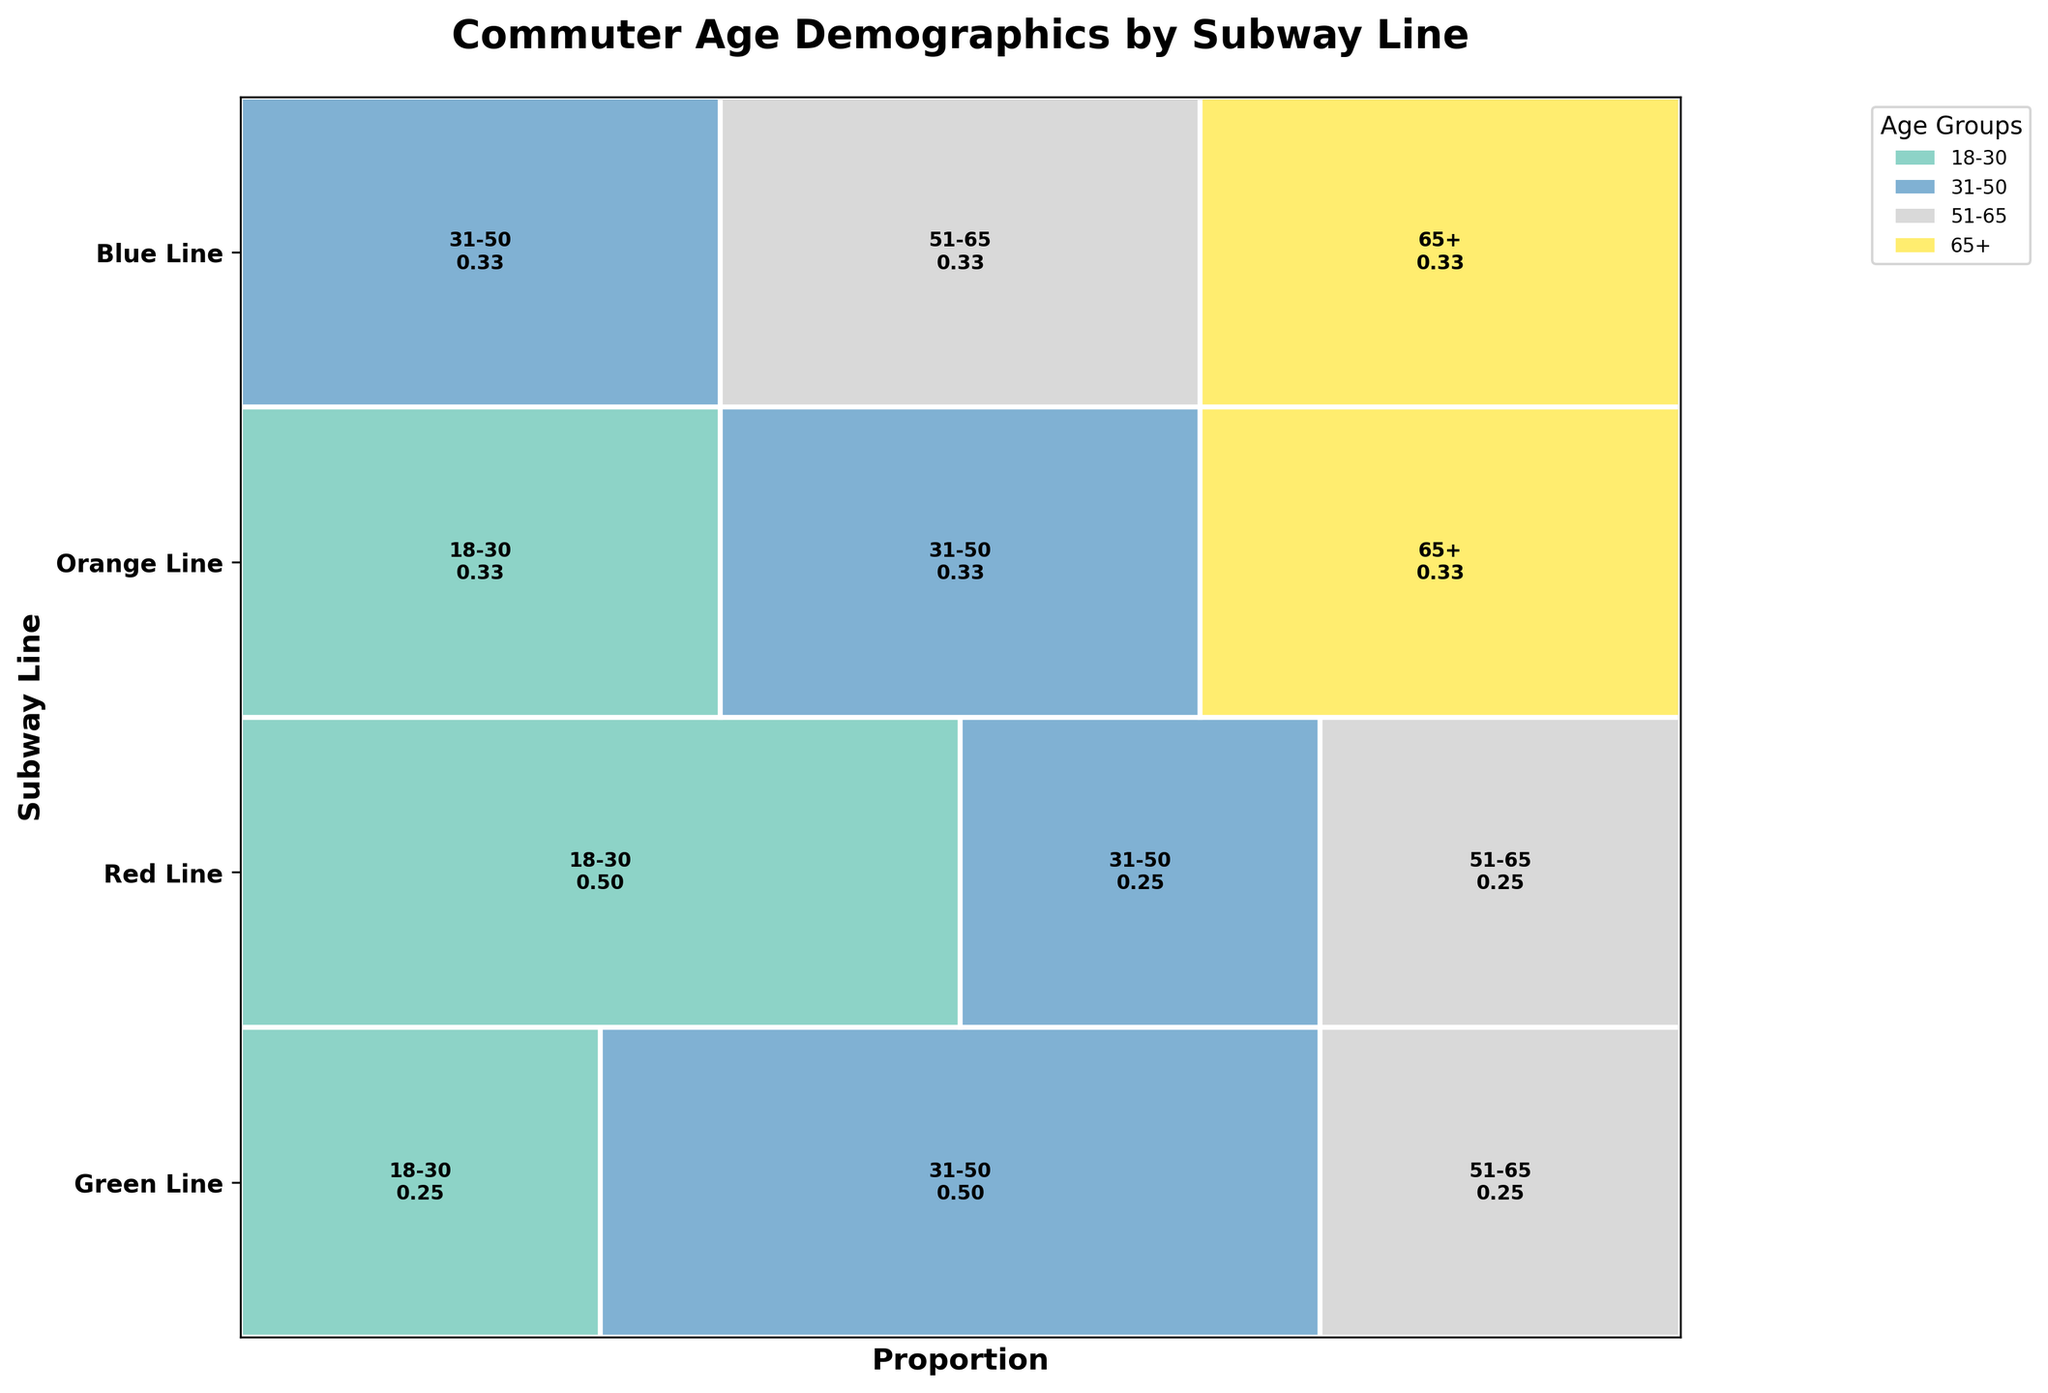Which subway line has the highest proportion of commuters aged 18-30? Look at the segments labeled '18-30' in the Mosaic Plot. Compare their widths across different subway lines.
Answer: Red Line What is the largest age group in the Green Line? Find the  Green Line row and check which age group segment is the widest within that row.
Answer: 31-50 Between the Red Line and the Blue Line, which one has a higher proportion of commuters aged 65+? Compare the width of the '65+' segment between the Red Line and Blue Line. The wider segment indicates a higher proportion.
Answer: Blue Line Which age group appears most frequently across all subway lines? Add the widths of each age group across all lines and compare them to identify the most frequent age group.
Answer: 31-50 How does the proportion of age group 18-30 in the Orange Line compare with that in the Green Line? Compare the widths of the segments labeled '18-30' in the Orange Line row and the Green Line row to see which is wider.
Answer: Green Line proportion is larger What age group has the smallest proportion on the Blue Line? Look at the Blue Line row and identify the smallest segment by comparing the widths.
Answer: 18-30 Which subway line has the most balanced age group distribution, i.e., segments that are closest in size? Examine the proportion widths of different age groups for each subway line and identify the line where the widths are most evenly distributed.
Answer: Orange Line Is the proportion of commuters aged 31-50 higher in the Red Line or the Green Line? Compare the width of the '31-50' segments between the Red Line and Green Line to see which is wider.
Answer: Green Line What subway line has the lowest proportion of professional commuters based on the age group 51-65? Locate the '51-65' segments that are linked to professional commuters in each subway row, then find the smallest segment width across the lines.
Answer: Green Line Are there any age groups that do not appear in the Green Line? Look at the Green Line row to see which age group segments, if any, are missing entirely.
Answer: 65+ 